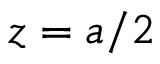Convert formula to latex. <formula><loc_0><loc_0><loc_500><loc_500>z = a / 2</formula> 